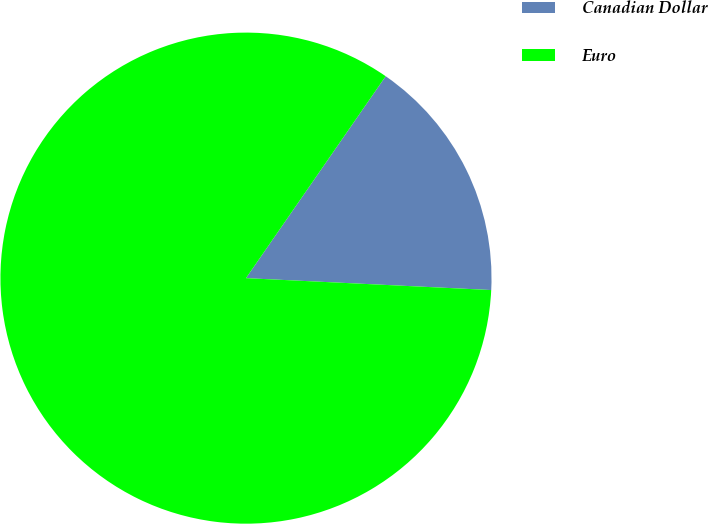Convert chart. <chart><loc_0><loc_0><loc_500><loc_500><pie_chart><fcel>Canadian Dollar<fcel>Euro<nl><fcel>16.14%<fcel>83.86%<nl></chart> 